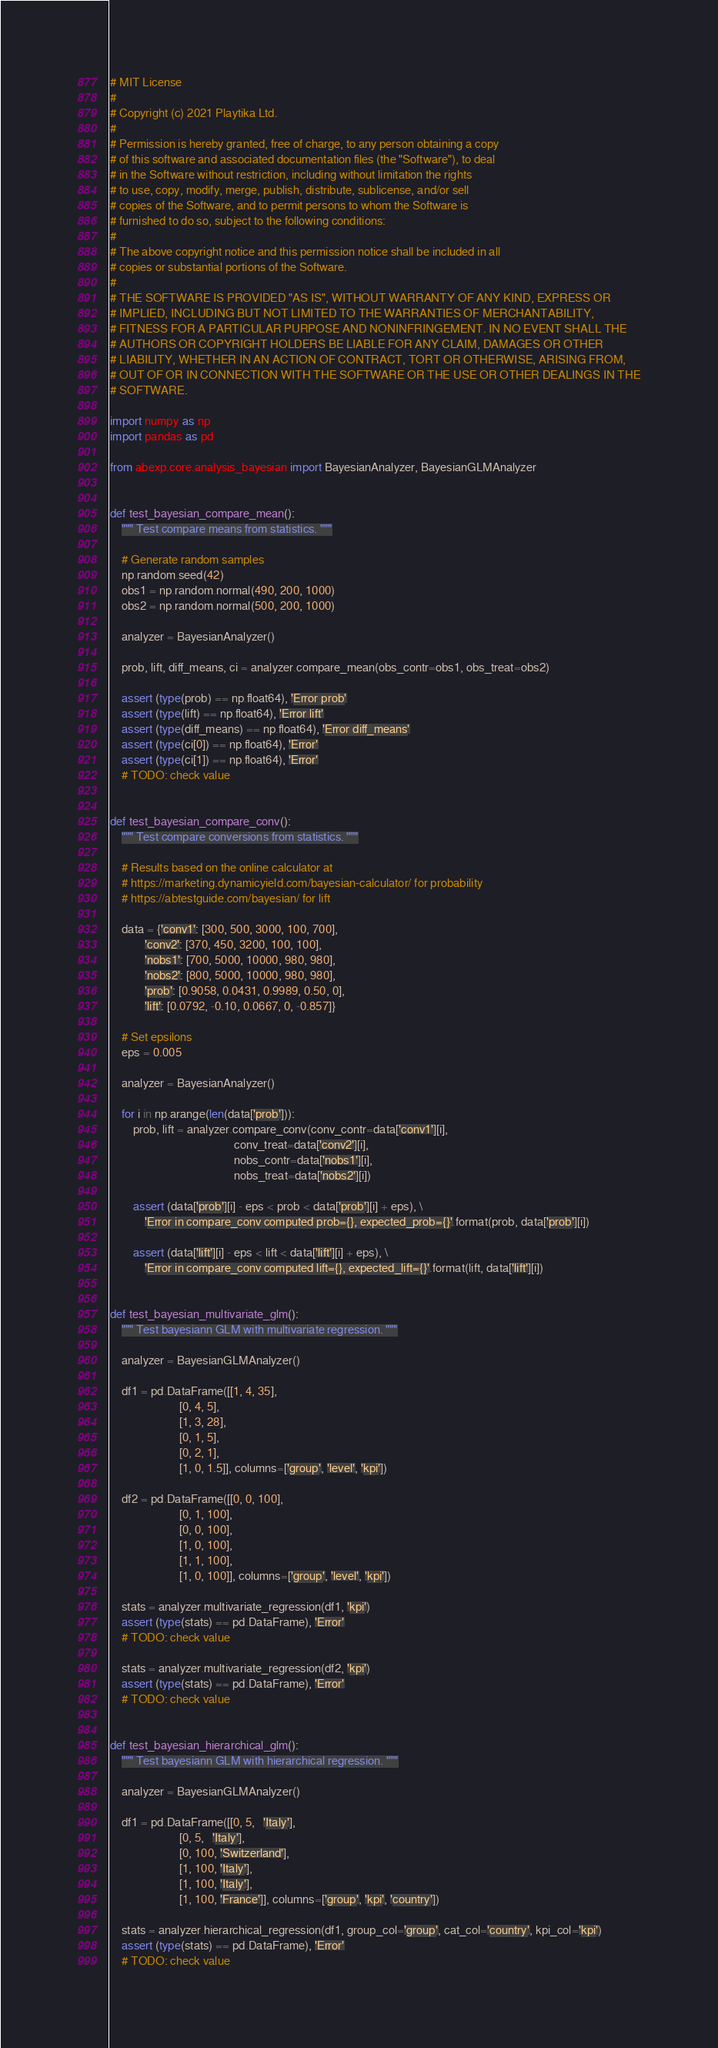Convert code to text. <code><loc_0><loc_0><loc_500><loc_500><_Python_># MIT License
# 
# Copyright (c) 2021 Playtika Ltd.
# 
# Permission is hereby granted, free of charge, to any person obtaining a copy
# of this software and associated documentation files (the "Software"), to deal
# in the Software without restriction, including without limitation the rights
# to use, copy, modify, merge, publish, distribute, sublicense, and/or sell
# copies of the Software, and to permit persons to whom the Software is
# furnished to do so, subject to the following conditions:
# 
# The above copyright notice and this permission notice shall be included in all
# copies or substantial portions of the Software.
# 
# THE SOFTWARE IS PROVIDED "AS IS", WITHOUT WARRANTY OF ANY KIND, EXPRESS OR
# IMPLIED, INCLUDING BUT NOT LIMITED TO THE WARRANTIES OF MERCHANTABILITY,
# FITNESS FOR A PARTICULAR PURPOSE AND NONINFRINGEMENT. IN NO EVENT SHALL THE
# AUTHORS OR COPYRIGHT HOLDERS BE LIABLE FOR ANY CLAIM, DAMAGES OR OTHER
# LIABILITY, WHETHER IN AN ACTION OF CONTRACT, TORT OR OTHERWISE, ARISING FROM,
# OUT OF OR IN CONNECTION WITH THE SOFTWARE OR THE USE OR OTHER DEALINGS IN THE
# SOFTWARE.

import numpy as np
import pandas as pd

from abexp.core.analysis_bayesian import BayesianAnalyzer, BayesianGLMAnalyzer


def test_bayesian_compare_mean():
    """ Test compare means from statistics. """

    # Generate random samples
    np.random.seed(42)
    obs1 = np.random.normal(490, 200, 1000)
    obs2 = np.random.normal(500, 200, 1000)

    analyzer = BayesianAnalyzer()

    prob, lift, diff_means, ci = analyzer.compare_mean(obs_contr=obs1, obs_treat=obs2)

    assert (type(prob) == np.float64), 'Error prob'
    assert (type(lift) == np.float64), 'Error lift'
    assert (type(diff_means) == np.float64), 'Error diff_means'
    assert (type(ci[0]) == np.float64), 'Error'
    assert (type(ci[1]) == np.float64), 'Error'
    # TODO: check value


def test_bayesian_compare_conv():
    """ Test compare conversions from statistics. """

    # Results based on the online calculator at
    # https://marketing.dynamicyield.com/bayesian-calculator/ for probability
    # https://abtestguide.com/bayesian/ for lift

    data = {'conv1': [300, 500, 3000, 100, 700],
            'conv2': [370, 450, 3200, 100, 100],
            'nobs1': [700, 5000, 10000, 980, 980],
            'nobs2': [800, 5000, 10000, 980, 980],
            'prob': [0.9058, 0.0431, 0.9989, 0.50, 0],
            'lift': [0.0792, -0.10, 0.0667, 0, -0.857]}

    # Set epsilons
    eps = 0.005

    analyzer = BayesianAnalyzer()

    for i in np.arange(len(data['prob'])):
        prob, lift = analyzer.compare_conv(conv_contr=data['conv1'][i],
                                           conv_treat=data['conv2'][i],
                                           nobs_contr=data['nobs1'][i],
                                           nobs_treat=data['nobs2'][i])

        assert (data['prob'][i] - eps < prob < data['prob'][i] + eps), \
            'Error in compare_conv computed prob={}, expected_prob={}'.format(prob, data['prob'][i])

        assert (data['lift'][i] - eps < lift < data['lift'][i] + eps), \
            'Error in compare_conv computed lift={}, expected_lift={}'.format(lift, data['lift'][i])


def test_bayesian_multivariate_glm():
    """ Test bayesiann GLM with multivariate regression. """

    analyzer = BayesianGLMAnalyzer()

    df1 = pd.DataFrame([[1, 4, 35],
                        [0, 4, 5],
                        [1, 3, 28],
                        [0, 1, 5],
                        [0, 2, 1],
                        [1, 0, 1.5]], columns=['group', 'level', 'kpi'])

    df2 = pd.DataFrame([[0, 0, 100],
                        [0, 1, 100],
                        [0, 0, 100],
                        [1, 0, 100],
                        [1, 1, 100],
                        [1, 0, 100]], columns=['group', 'level', 'kpi'])

    stats = analyzer.multivariate_regression(df1, 'kpi')
    assert (type(stats) == pd.DataFrame), 'Error'
    # TODO: check value

    stats = analyzer.multivariate_regression(df2, 'kpi')
    assert (type(stats) == pd.DataFrame), 'Error'
    # TODO: check value


def test_bayesian_hierarchical_glm():
    """ Test bayesiann GLM with hierarchical regression. """

    analyzer = BayesianGLMAnalyzer()

    df1 = pd.DataFrame([[0, 5,   'Italy'],
                        [0, 5,   'Italy'],
                        [0, 100, 'Switzerland'],
                        [1, 100, 'Italy'],
                        [1, 100, 'Italy'],
                        [1, 100, 'France']], columns=['group', 'kpi', 'country'])

    stats = analyzer.hierarchical_regression(df1, group_col='group', cat_col='country', kpi_col='kpi')
    assert (type(stats) == pd.DataFrame), 'Error'
    # TODO: check value
</code> 